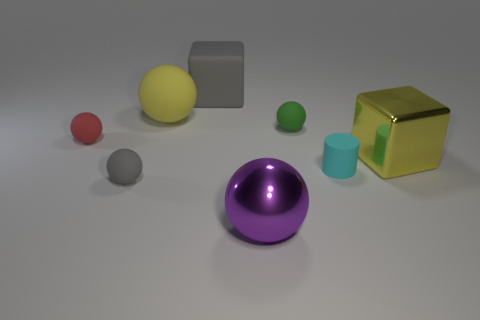There is a block that is right of the big gray object; is its color the same as the large sphere that is behind the tiny cyan matte cylinder?
Provide a succinct answer. Yes. What number of other objects are there of the same size as the yellow sphere?
Ensure brevity in your answer.  3. How many objects are big gray rubber blocks or shiny objects right of the shiny sphere?
Ensure brevity in your answer.  2. Are there the same number of big metal spheres to the right of the large purple ball and yellow matte balls?
Offer a terse response. No. What is the shape of the big object that is made of the same material as the yellow ball?
Offer a very short reply. Cube. Are there any small matte objects that have the same color as the rubber cube?
Offer a very short reply. Yes. What number of rubber objects are gray objects or tiny cyan things?
Your answer should be very brief. 3. How many gray rubber cubes are in front of the matte sphere in front of the large metal block?
Make the answer very short. 0. What number of gray objects are made of the same material as the gray cube?
Your answer should be very brief. 1. What number of small objects are either purple cylinders or red balls?
Provide a succinct answer. 1. 